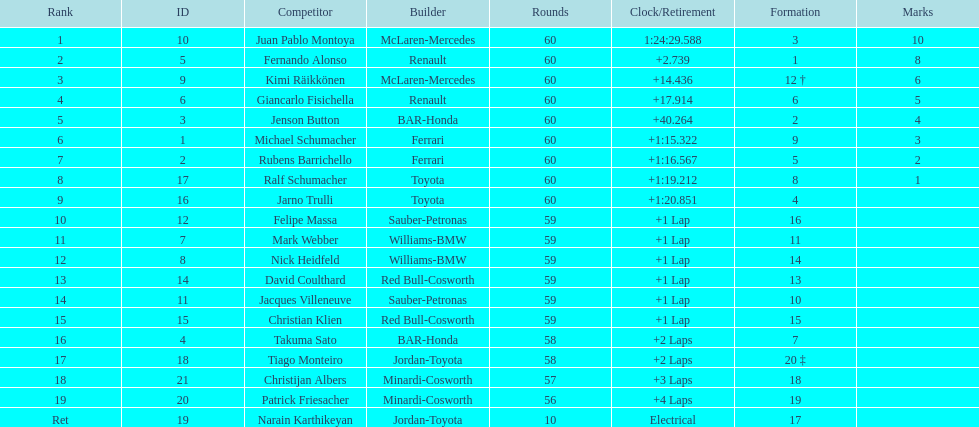Which driver has the least amount of points? Ralf Schumacher. 